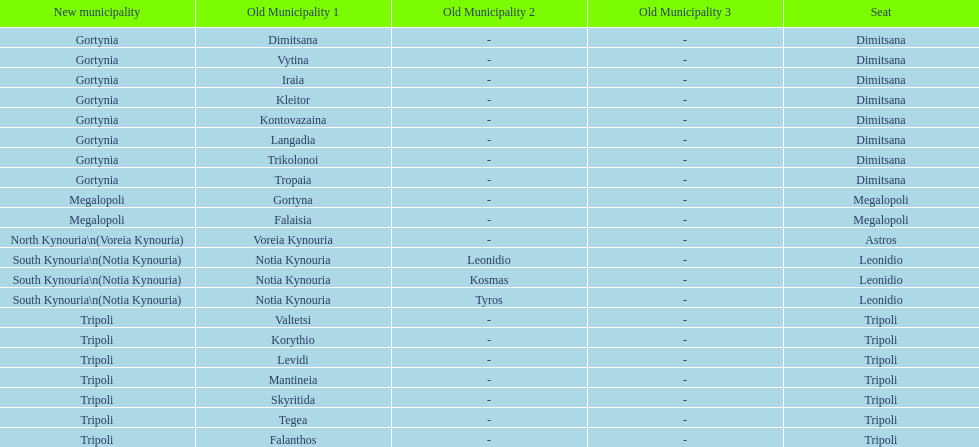When arcadia was reformed in 2011, how many municipalities were created? 5. 